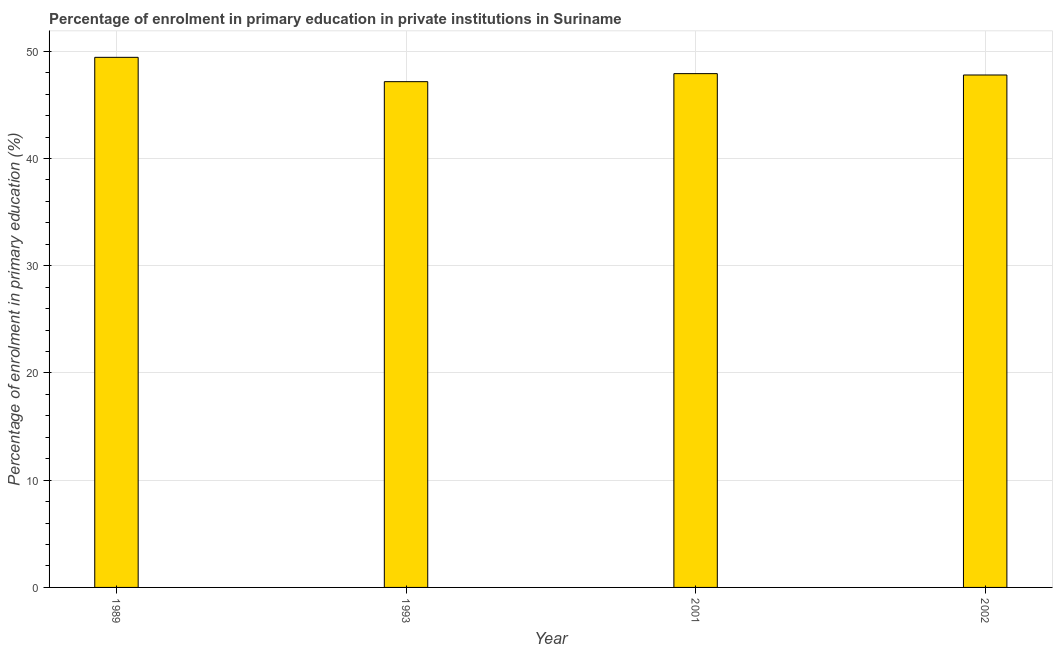Does the graph contain grids?
Provide a short and direct response. Yes. What is the title of the graph?
Provide a short and direct response. Percentage of enrolment in primary education in private institutions in Suriname. What is the label or title of the X-axis?
Your answer should be compact. Year. What is the label or title of the Y-axis?
Offer a terse response. Percentage of enrolment in primary education (%). What is the enrolment percentage in primary education in 1993?
Provide a succinct answer. 47.17. Across all years, what is the maximum enrolment percentage in primary education?
Make the answer very short. 49.44. Across all years, what is the minimum enrolment percentage in primary education?
Ensure brevity in your answer.  47.17. In which year was the enrolment percentage in primary education minimum?
Make the answer very short. 1993. What is the sum of the enrolment percentage in primary education?
Ensure brevity in your answer.  192.33. What is the difference between the enrolment percentage in primary education in 1993 and 2001?
Provide a succinct answer. -0.75. What is the average enrolment percentage in primary education per year?
Give a very brief answer. 48.08. What is the median enrolment percentage in primary education?
Make the answer very short. 47.86. In how many years, is the enrolment percentage in primary education greater than 2 %?
Your answer should be compact. 4. Do a majority of the years between 2002 and 2001 (inclusive) have enrolment percentage in primary education greater than 22 %?
Keep it short and to the point. No. What is the ratio of the enrolment percentage in primary education in 1989 to that in 2001?
Keep it short and to the point. 1.03. What is the difference between the highest and the second highest enrolment percentage in primary education?
Make the answer very short. 1.52. Is the sum of the enrolment percentage in primary education in 1989 and 1993 greater than the maximum enrolment percentage in primary education across all years?
Provide a short and direct response. Yes. What is the difference between the highest and the lowest enrolment percentage in primary education?
Give a very brief answer. 2.27. How many bars are there?
Provide a succinct answer. 4. How many years are there in the graph?
Offer a terse response. 4. Are the values on the major ticks of Y-axis written in scientific E-notation?
Provide a short and direct response. No. What is the Percentage of enrolment in primary education (%) of 1989?
Make the answer very short. 49.44. What is the Percentage of enrolment in primary education (%) of 1993?
Give a very brief answer. 47.17. What is the Percentage of enrolment in primary education (%) in 2001?
Keep it short and to the point. 47.92. What is the Percentage of enrolment in primary education (%) of 2002?
Ensure brevity in your answer.  47.79. What is the difference between the Percentage of enrolment in primary education (%) in 1989 and 1993?
Your answer should be very brief. 2.27. What is the difference between the Percentage of enrolment in primary education (%) in 1989 and 2001?
Your answer should be compact. 1.52. What is the difference between the Percentage of enrolment in primary education (%) in 1989 and 2002?
Provide a succinct answer. 1.65. What is the difference between the Percentage of enrolment in primary education (%) in 1993 and 2001?
Provide a short and direct response. -0.75. What is the difference between the Percentage of enrolment in primary education (%) in 1993 and 2002?
Keep it short and to the point. -0.62. What is the difference between the Percentage of enrolment in primary education (%) in 2001 and 2002?
Ensure brevity in your answer.  0.13. What is the ratio of the Percentage of enrolment in primary education (%) in 1989 to that in 1993?
Give a very brief answer. 1.05. What is the ratio of the Percentage of enrolment in primary education (%) in 1989 to that in 2001?
Offer a terse response. 1.03. What is the ratio of the Percentage of enrolment in primary education (%) in 1989 to that in 2002?
Provide a short and direct response. 1.03. What is the ratio of the Percentage of enrolment in primary education (%) in 1993 to that in 2002?
Provide a short and direct response. 0.99. What is the ratio of the Percentage of enrolment in primary education (%) in 2001 to that in 2002?
Provide a succinct answer. 1. 